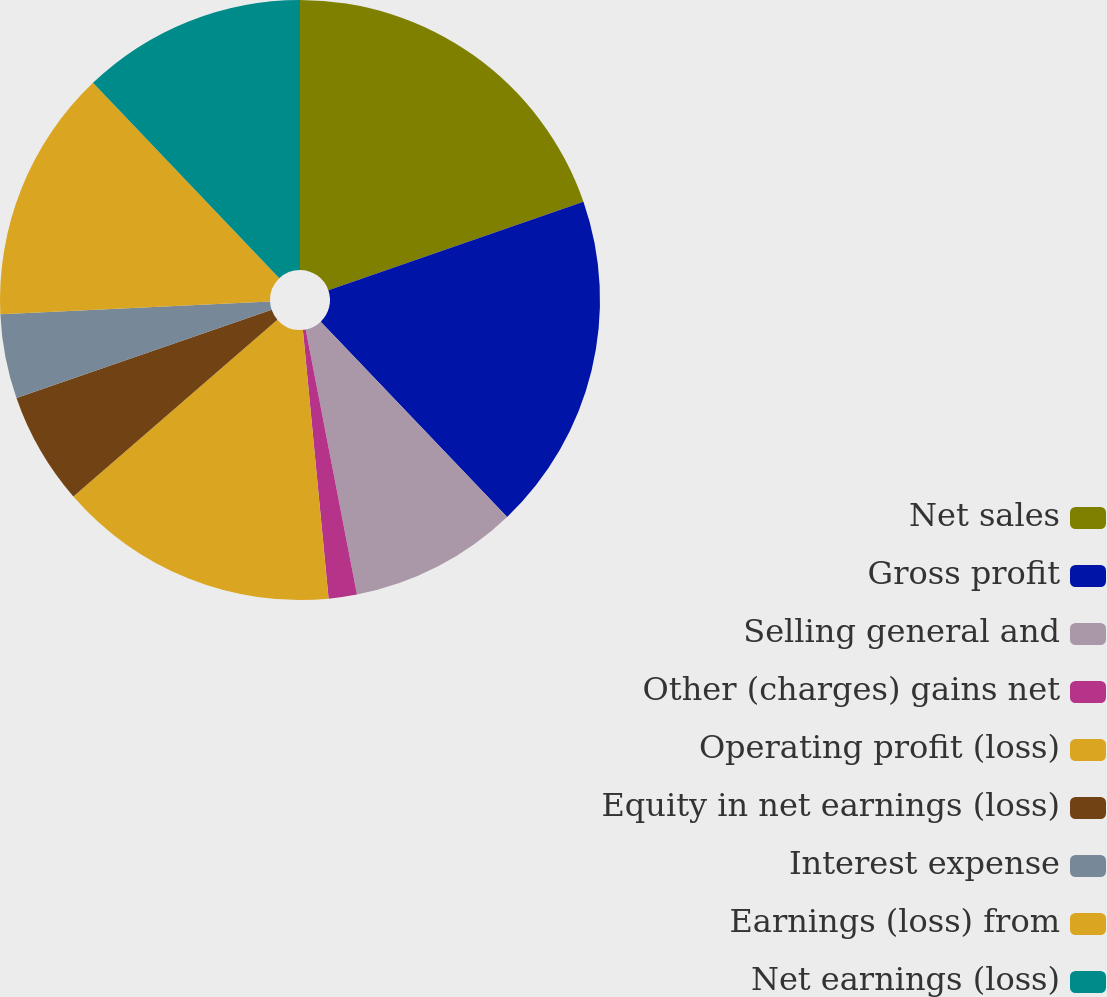Convert chart to OTSL. <chart><loc_0><loc_0><loc_500><loc_500><pie_chart><fcel>Net sales<fcel>Gross profit<fcel>Selling general and<fcel>Other (charges) gains net<fcel>Operating profit (loss)<fcel>Equity in net earnings (loss)<fcel>Interest expense<fcel>Earnings (loss) from<fcel>Net earnings (loss)<nl><fcel>19.69%<fcel>18.18%<fcel>9.09%<fcel>1.52%<fcel>15.15%<fcel>6.07%<fcel>4.55%<fcel>13.63%<fcel>12.12%<nl></chart> 